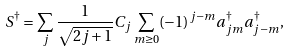<formula> <loc_0><loc_0><loc_500><loc_500>S ^ { \dagger } = \sum _ { j } \frac { 1 } { \sqrt { 2 j + 1 } } C _ { j } \sum _ { m \geq 0 } ( - 1 ) ^ { j - m } a ^ { \dagger } _ { j m } a ^ { \dagger } _ { j - m } ,</formula> 